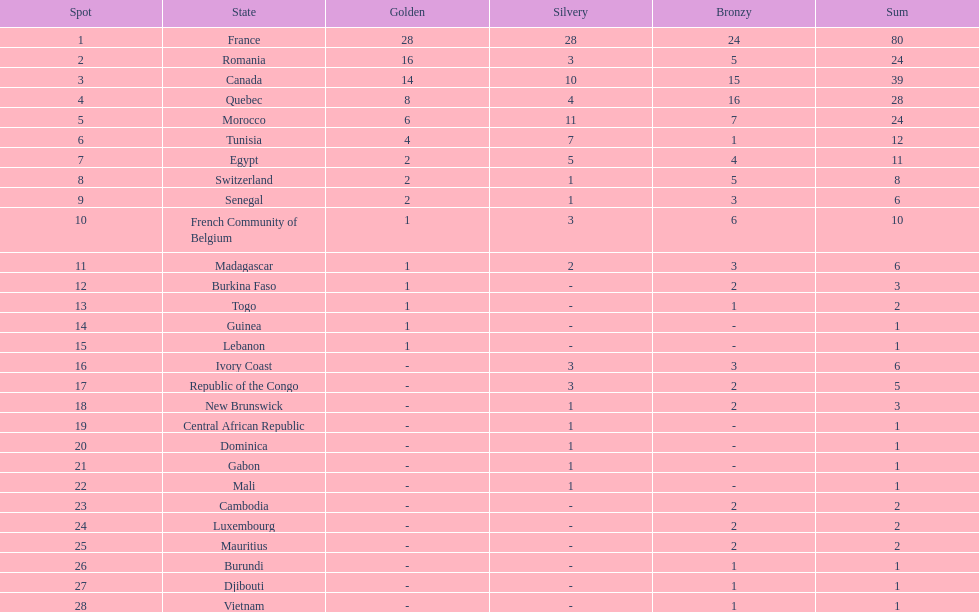How many nations won at least 10 medals? 8. 